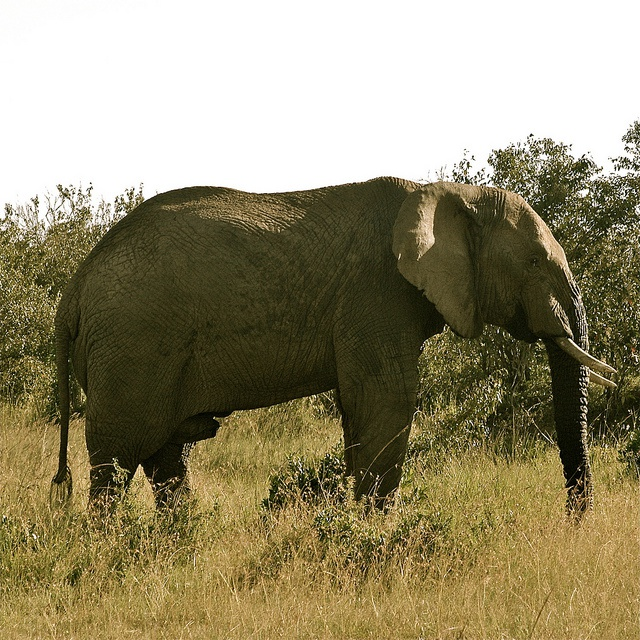Describe the objects in this image and their specific colors. I can see a elephant in white, black, darkgreen, and tan tones in this image. 